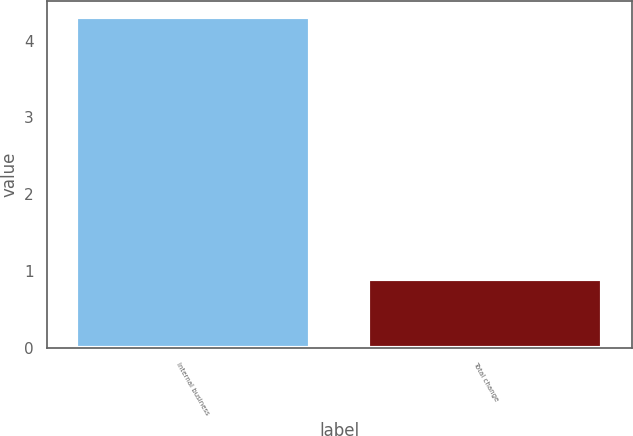<chart> <loc_0><loc_0><loc_500><loc_500><bar_chart><fcel>Internal business<fcel>Total change<nl><fcel>4.3<fcel>0.9<nl></chart> 